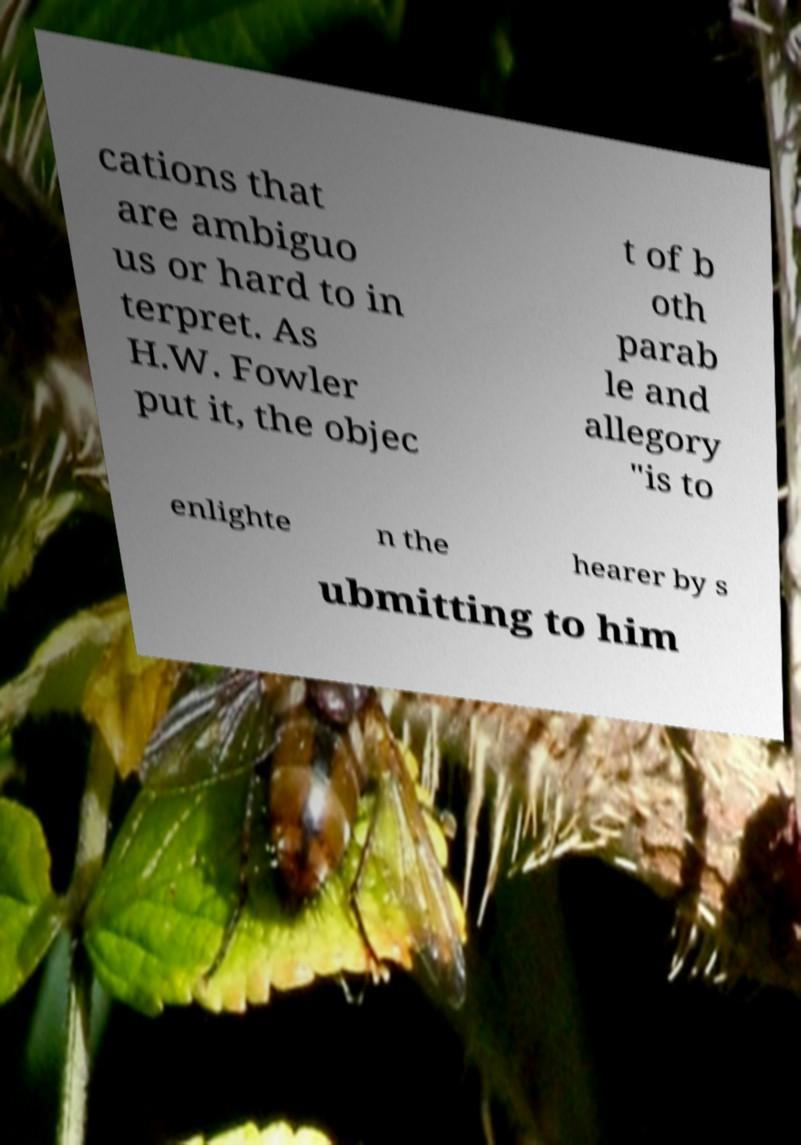Please read and relay the text visible in this image. What does it say? cations that are ambiguo us or hard to in terpret. As H.W. Fowler put it, the objec t of b oth parab le and allegory "is to enlighte n the hearer by s ubmitting to him 